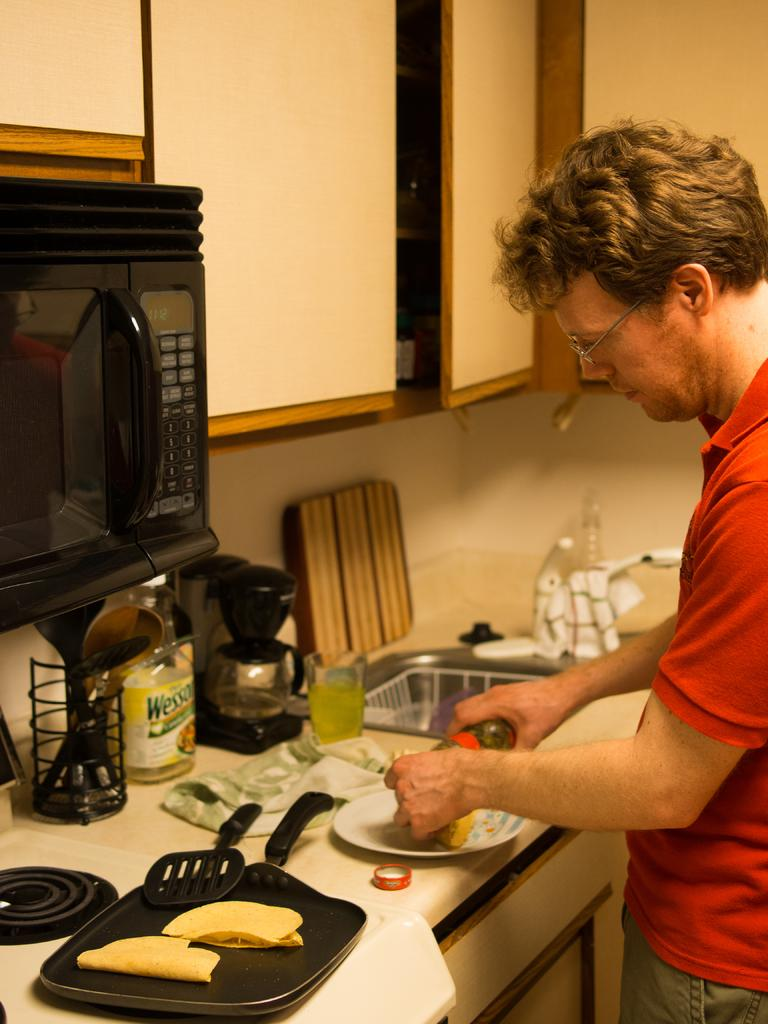<image>
Share a concise interpretation of the image provided. A man prepares a meal on the counter in front of a bottle of Wesson oil. 